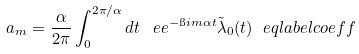<formula> <loc_0><loc_0><loc_500><loc_500>a _ { m } = \frac { \alpha } { 2 \pi } \int _ { 0 } ^ { 2 \pi / \alpha } d t \, \ e e ^ { - \i i m \alpha t } \tilde { \lambda } _ { 0 } ( t ) \ e q l a b e l { c o e f f }</formula> 